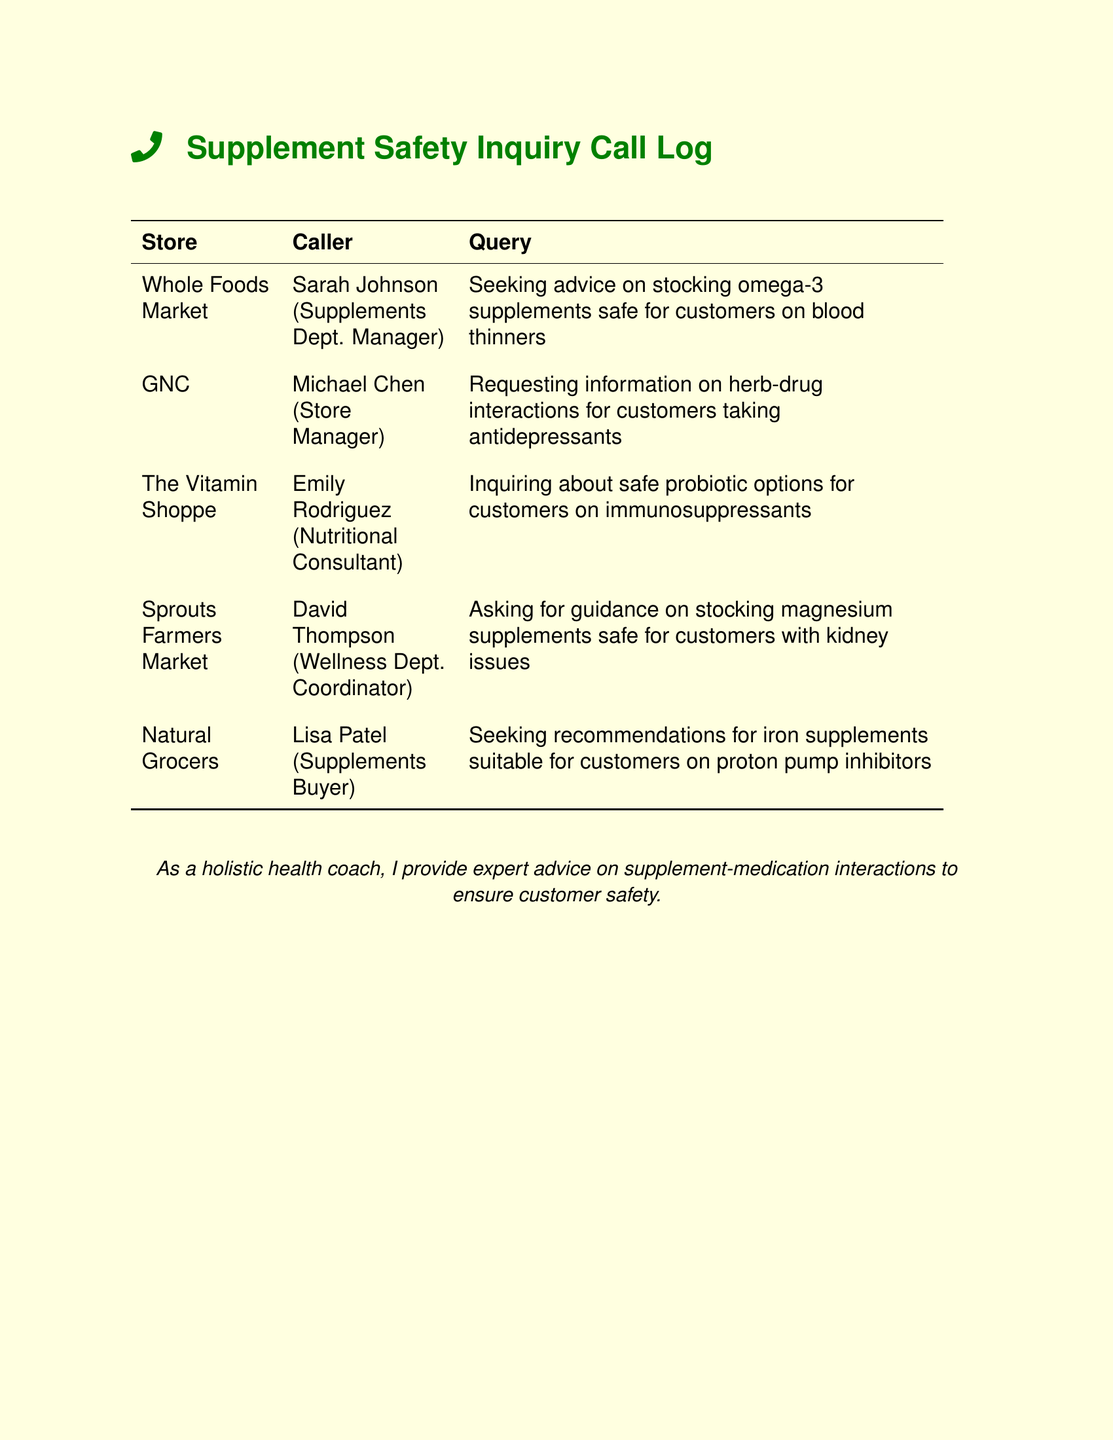What is the name of the first store listed? The first store listed is Whole Foods Market.
Answer: Whole Foods Market Who called from GNC? The caller from GNC is Michael Chen, the Store Manager.
Answer: Michael Chen What supplement is being inquired about for immunosuppressants? The inquiry is about safe probiotic options.
Answer: Probiotics What medication category is connected to the inquiry from Natural Grocers? The inquiry is related to proton pump inhibitors.
Answer: Proton pump inhibitors How many stores are mentioned in the document? The document mentions a total of five stores.
Answer: Five Who is seeking advice on magnesium supplements? David Thompson from Sprouts Farmers Market is asking for guidance.
Answer: David Thompson Which store is asking about omega-3 supplements? Whole Foods Market is inquiring about omega-3 supplements.
Answer: Whole Foods Market What is the profession of Emily Rodriguez? Emily Rodriguez is a Nutritional Consultant.
Answer: Nutritional Consultant 